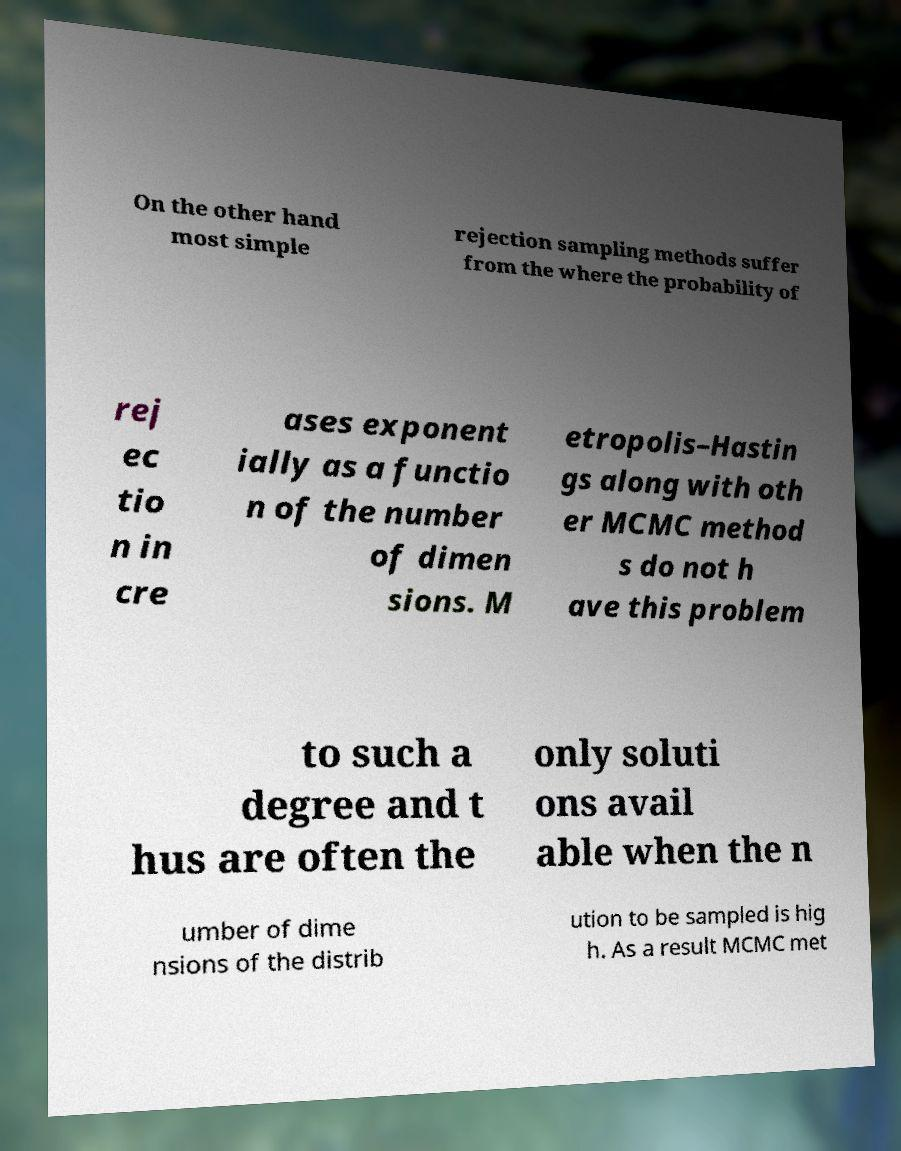Can you accurately transcribe the text from the provided image for me? On the other hand most simple rejection sampling methods suffer from the where the probability of rej ec tio n in cre ases exponent ially as a functio n of the number of dimen sions. M etropolis–Hastin gs along with oth er MCMC method s do not h ave this problem to such a degree and t hus are often the only soluti ons avail able when the n umber of dime nsions of the distrib ution to be sampled is hig h. As a result MCMC met 